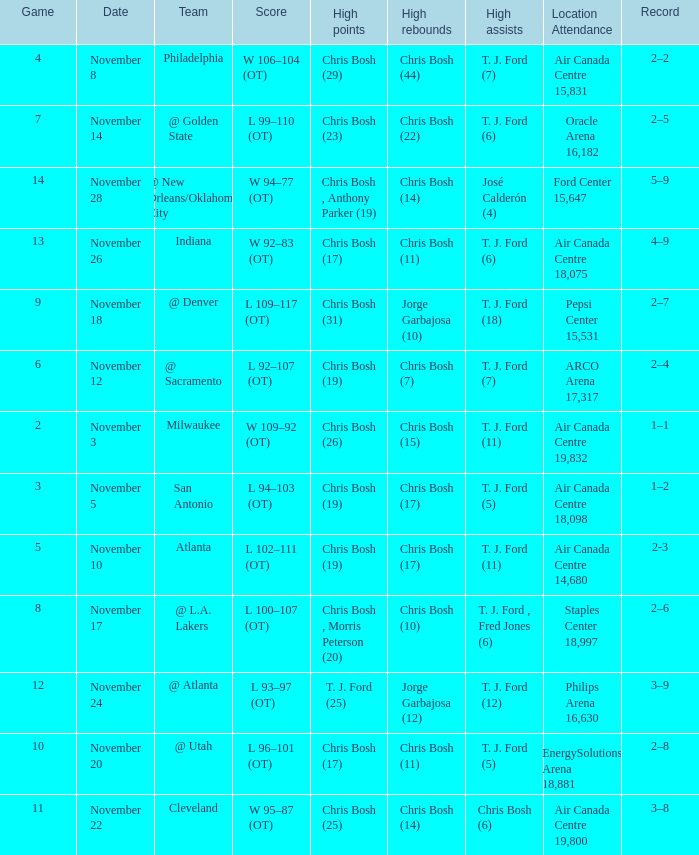Would you be able to parse every entry in this table? {'header': ['Game', 'Date', 'Team', 'Score', 'High points', 'High rebounds', 'High assists', 'Location Attendance', 'Record'], 'rows': [['4', 'November 8', 'Philadelphia', 'W 106–104 (OT)', 'Chris Bosh (29)', 'Chris Bosh (44)', 'T. J. Ford (7)', 'Air Canada Centre 15,831', '2–2'], ['7', 'November 14', '@ Golden State', 'L 99–110 (OT)', 'Chris Bosh (23)', 'Chris Bosh (22)', 'T. J. Ford (6)', 'Oracle Arena 16,182', '2–5'], ['14', 'November 28', '@ New Orleans/Oklahoma City', 'W 94–77 (OT)', 'Chris Bosh , Anthony Parker (19)', 'Chris Bosh (14)', 'José Calderón (4)', 'Ford Center 15,647', '5–9'], ['13', 'November 26', 'Indiana', 'W 92–83 (OT)', 'Chris Bosh (17)', 'Chris Bosh (11)', 'T. J. Ford (6)', 'Air Canada Centre 18,075', '4–9'], ['9', 'November 18', '@ Denver', 'L 109–117 (OT)', 'Chris Bosh (31)', 'Jorge Garbajosa (10)', 'T. J. Ford (18)', 'Pepsi Center 15,531', '2–7'], ['6', 'November 12', '@ Sacramento', 'L 92–107 (OT)', 'Chris Bosh (19)', 'Chris Bosh (7)', 'T. J. Ford (7)', 'ARCO Arena 17,317', '2–4'], ['2', 'November 3', 'Milwaukee', 'W 109–92 (OT)', 'Chris Bosh (26)', 'Chris Bosh (15)', 'T. J. Ford (11)', 'Air Canada Centre 19,832', '1–1'], ['3', 'November 5', 'San Antonio', 'L 94–103 (OT)', 'Chris Bosh (19)', 'Chris Bosh (17)', 'T. J. Ford (5)', 'Air Canada Centre 18,098', '1–2'], ['5', 'November 10', 'Atlanta', 'L 102–111 (OT)', 'Chris Bosh (19)', 'Chris Bosh (17)', 'T. J. Ford (11)', 'Air Canada Centre 14,680', '2-3'], ['8', 'November 17', '@ L.A. Lakers', 'L 100–107 (OT)', 'Chris Bosh , Morris Peterson (20)', 'Chris Bosh (10)', 'T. J. Ford , Fred Jones (6)', 'Staples Center 18,997', '2–6'], ['12', 'November 24', '@ Atlanta', 'L 93–97 (OT)', 'T. J. Ford (25)', 'Jorge Garbajosa (12)', 'T. J. Ford (12)', 'Philips Arena 16,630', '3–9'], ['10', 'November 20', '@ Utah', 'L 96–101 (OT)', 'Chris Bosh (17)', 'Chris Bosh (11)', 'T. J. Ford (5)', 'EnergySolutions Arena 18,881', '2–8'], ['11', 'November 22', 'Cleveland', 'W 95–87 (OT)', 'Chris Bosh (25)', 'Chris Bosh (14)', 'Chris Bosh (6)', 'Air Canada Centre 19,800', '3–8']]} Who had high assists when they played against San Antonio? T. J. Ford (5). 